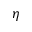<formula> <loc_0><loc_0><loc_500><loc_500>\eta</formula> 